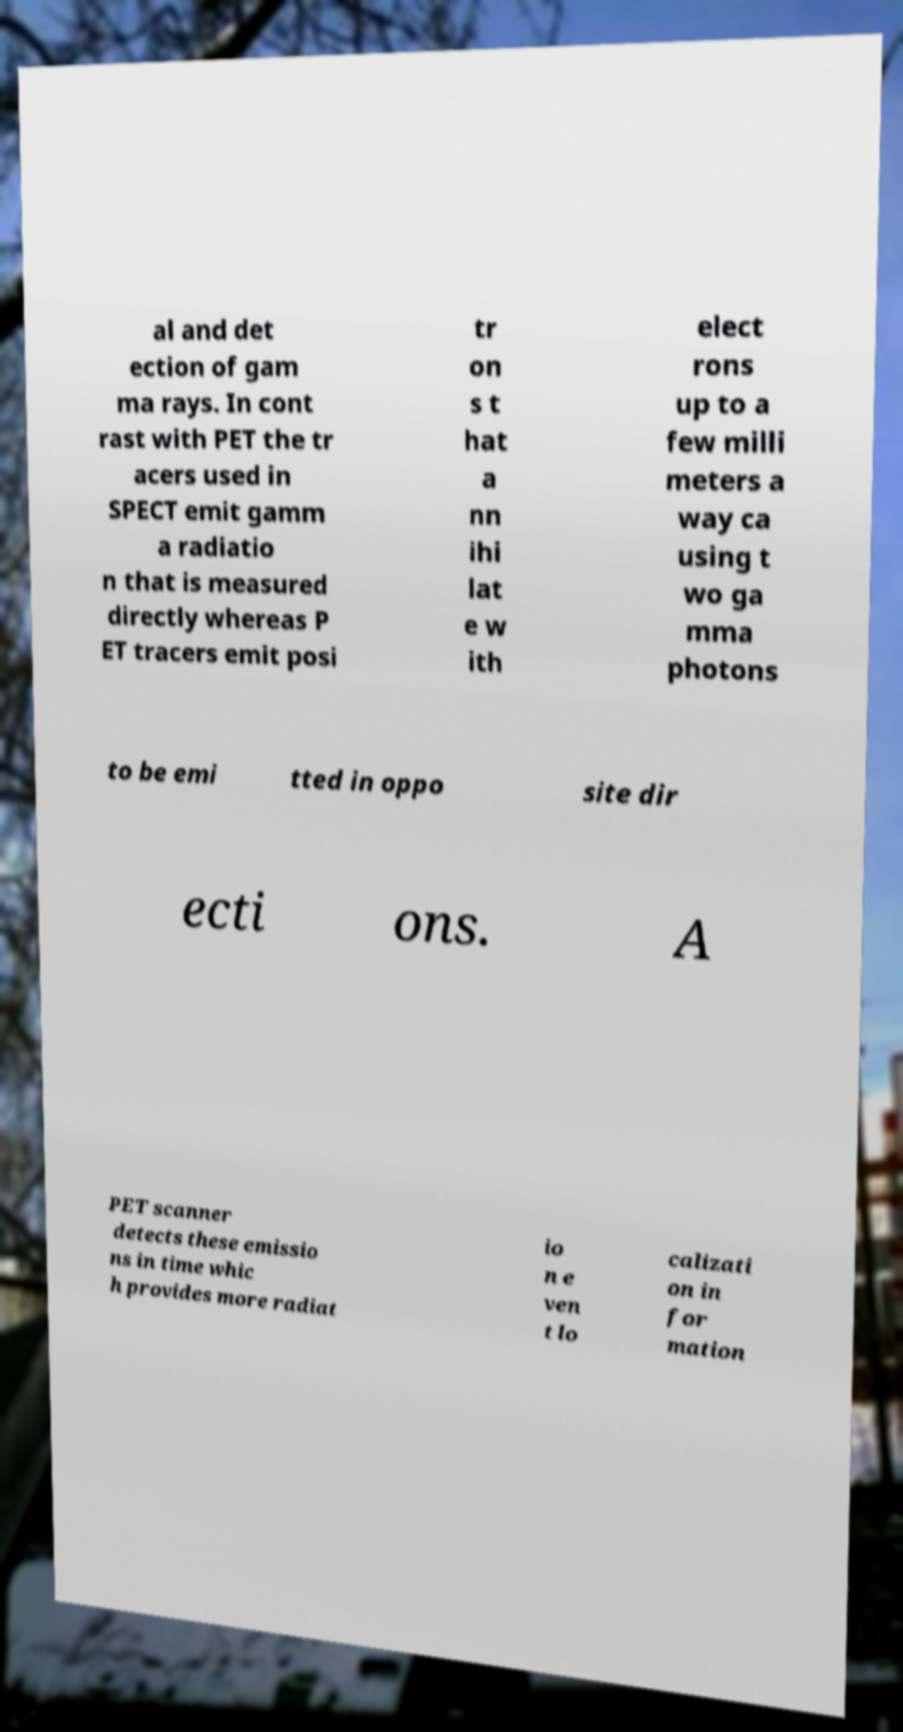Can you read and provide the text displayed in the image?This photo seems to have some interesting text. Can you extract and type it out for me? al and det ection of gam ma rays. In cont rast with PET the tr acers used in SPECT emit gamm a radiatio n that is measured directly whereas P ET tracers emit posi tr on s t hat a nn ihi lat e w ith elect rons up to a few milli meters a way ca using t wo ga mma photons to be emi tted in oppo site dir ecti ons. A PET scanner detects these emissio ns in time whic h provides more radiat io n e ven t lo calizati on in for mation 